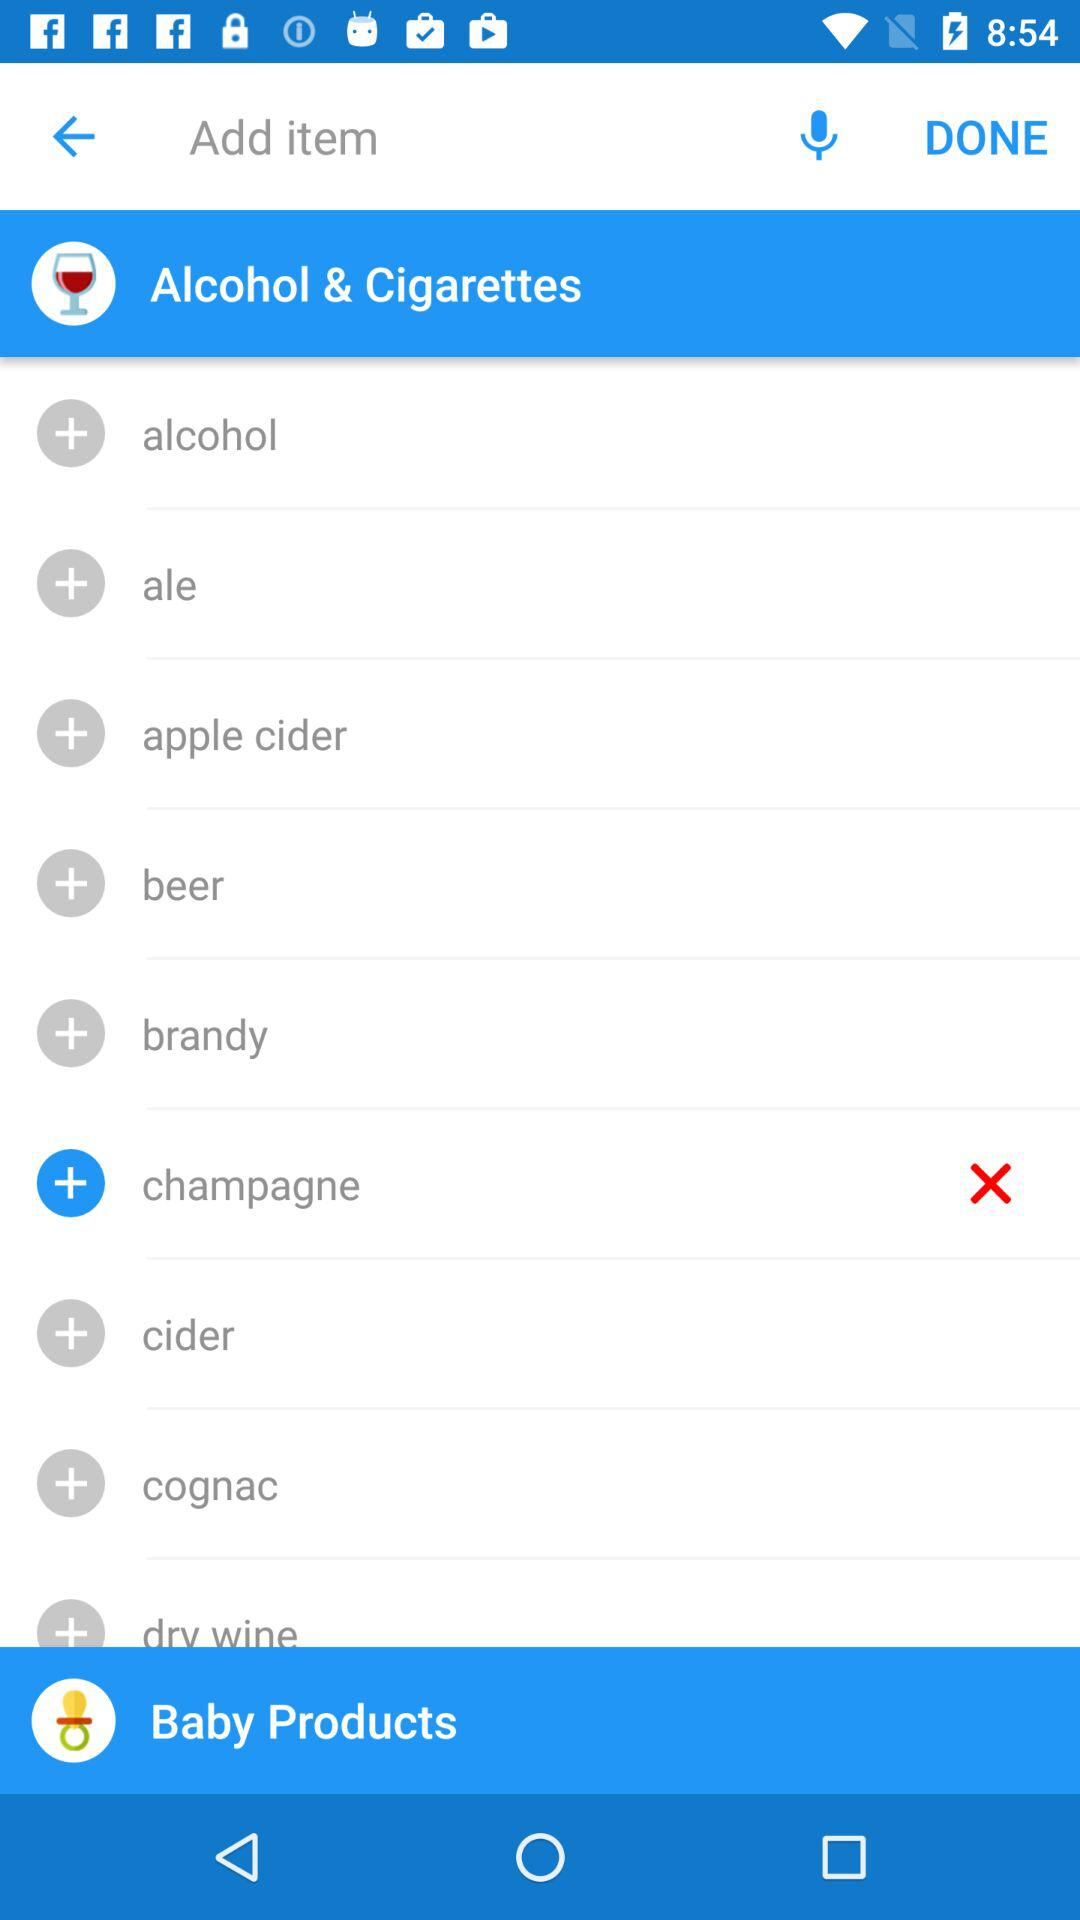Which baby products are selected?
When the provided information is insufficient, respond with <no answer>. <no answer> 